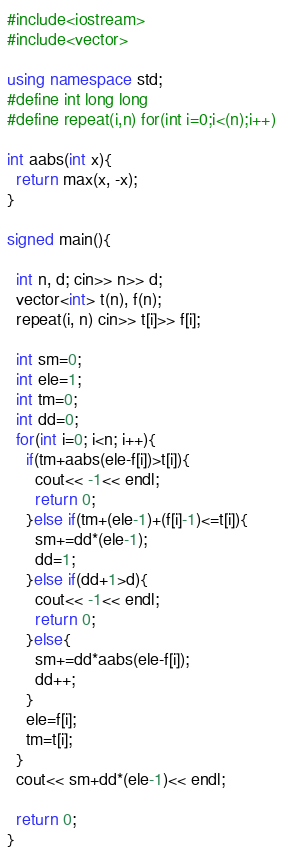<code> <loc_0><loc_0><loc_500><loc_500><_C++_>#include<iostream>
#include<vector>

using namespace std;
#define int long long
#define repeat(i,n) for(int i=0;i<(n);i++)

int aabs(int x){
  return max(x, -x);
}

signed main(){

  int n, d; cin>> n>> d;
  vector<int> t(n), f(n);
  repeat(i, n) cin>> t[i]>> f[i];

  int sm=0;
  int ele=1;
  int tm=0;
  int dd=0;
  for(int i=0; i<n; i++){
    if(tm+aabs(ele-f[i])>t[i]){
      cout<< -1<< endl;
      return 0;
    }else if(tm+(ele-1)+(f[i]-1)<=t[i]){
      sm+=dd*(ele-1);
      dd=1;
    }else if(dd+1>d){
      cout<< -1<< endl;
      return 0;
    }else{
      sm+=dd*aabs(ele-f[i]);
      dd++;
    }
    ele=f[i];
    tm=t[i];
  }
  cout<< sm+dd*(ele-1)<< endl;

  return 0;
}</code> 